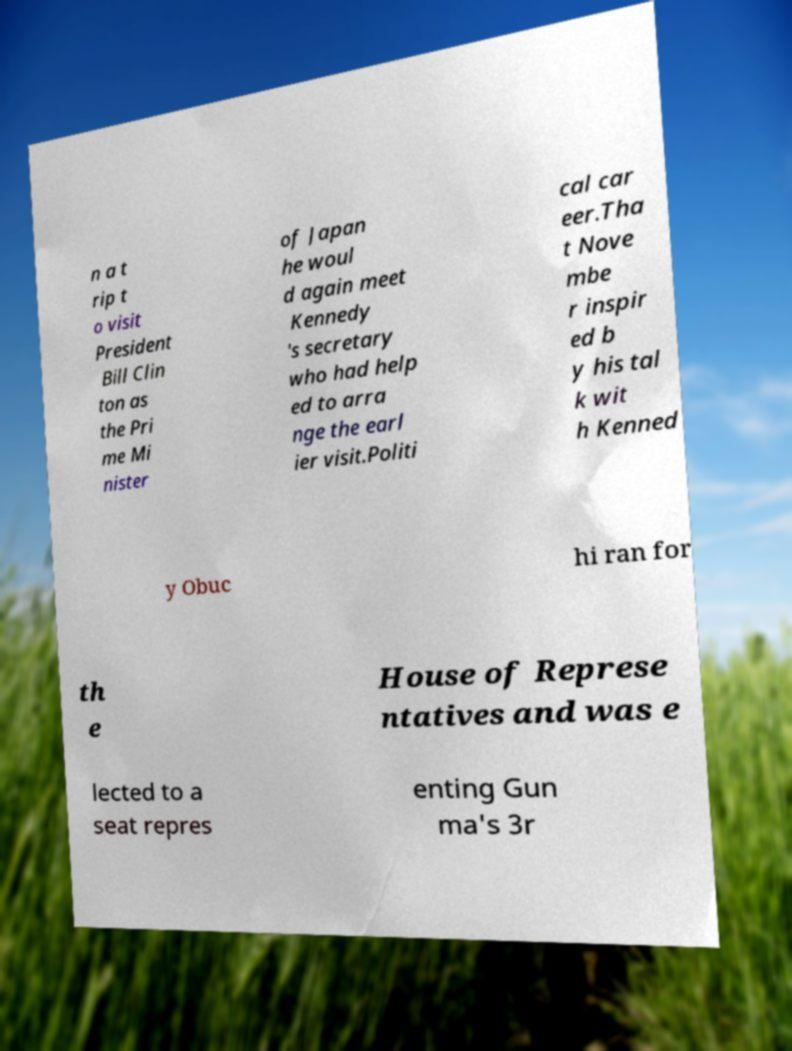What messages or text are displayed in this image? I need them in a readable, typed format. n a t rip t o visit President Bill Clin ton as the Pri me Mi nister of Japan he woul d again meet Kennedy 's secretary who had help ed to arra nge the earl ier visit.Politi cal car eer.Tha t Nove mbe r inspir ed b y his tal k wit h Kenned y Obuc hi ran for th e House of Represe ntatives and was e lected to a seat repres enting Gun ma's 3r 